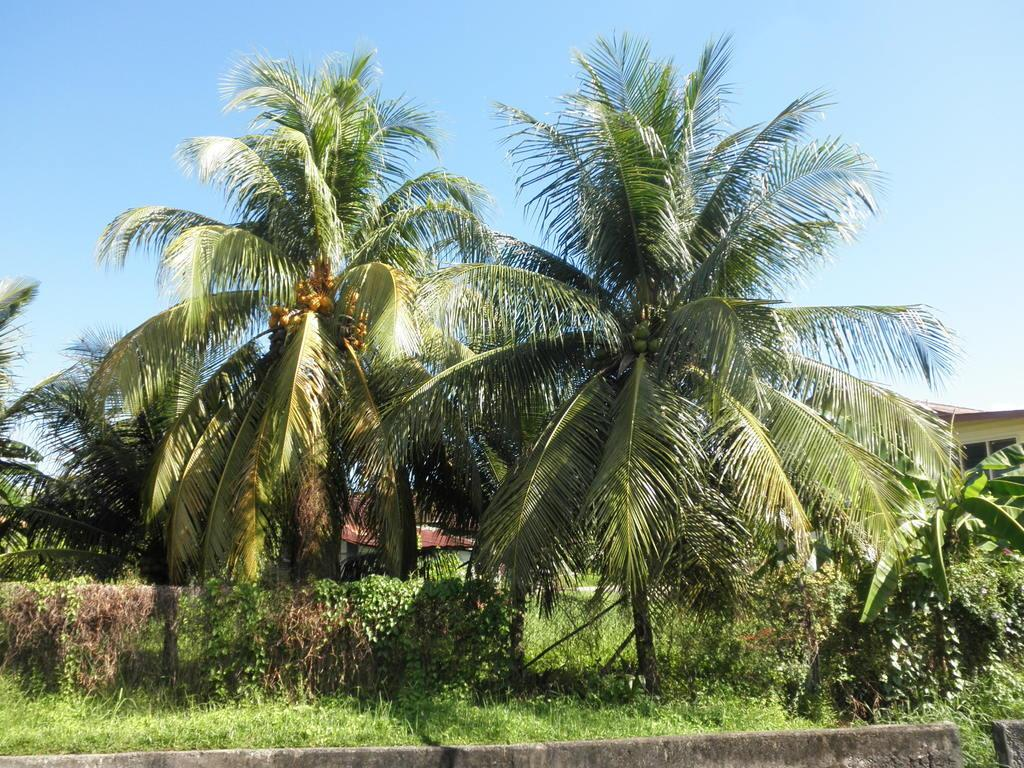What type of vegetation can be seen in the image? There are trees, plants, and grass in the image. What type of structures are present in the image? There are buildings in the image. What part of the natural environment is visible in the image? The sky is visible in the image. What type of animals can be seen at the zoo in the image? There is no zoo present in the image, so it is not possible to determine what type of animals might be seen there. 